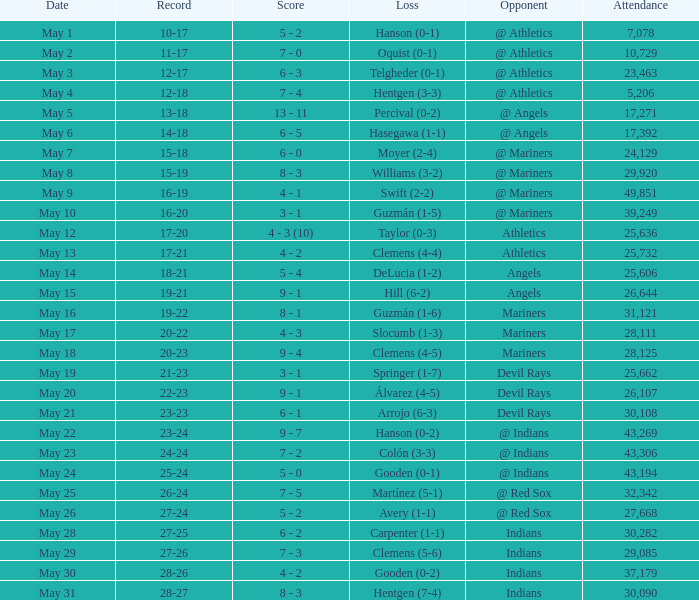When the record is 16-20 and attendance is greater than 32,342, what is the score? 3 - 1. 